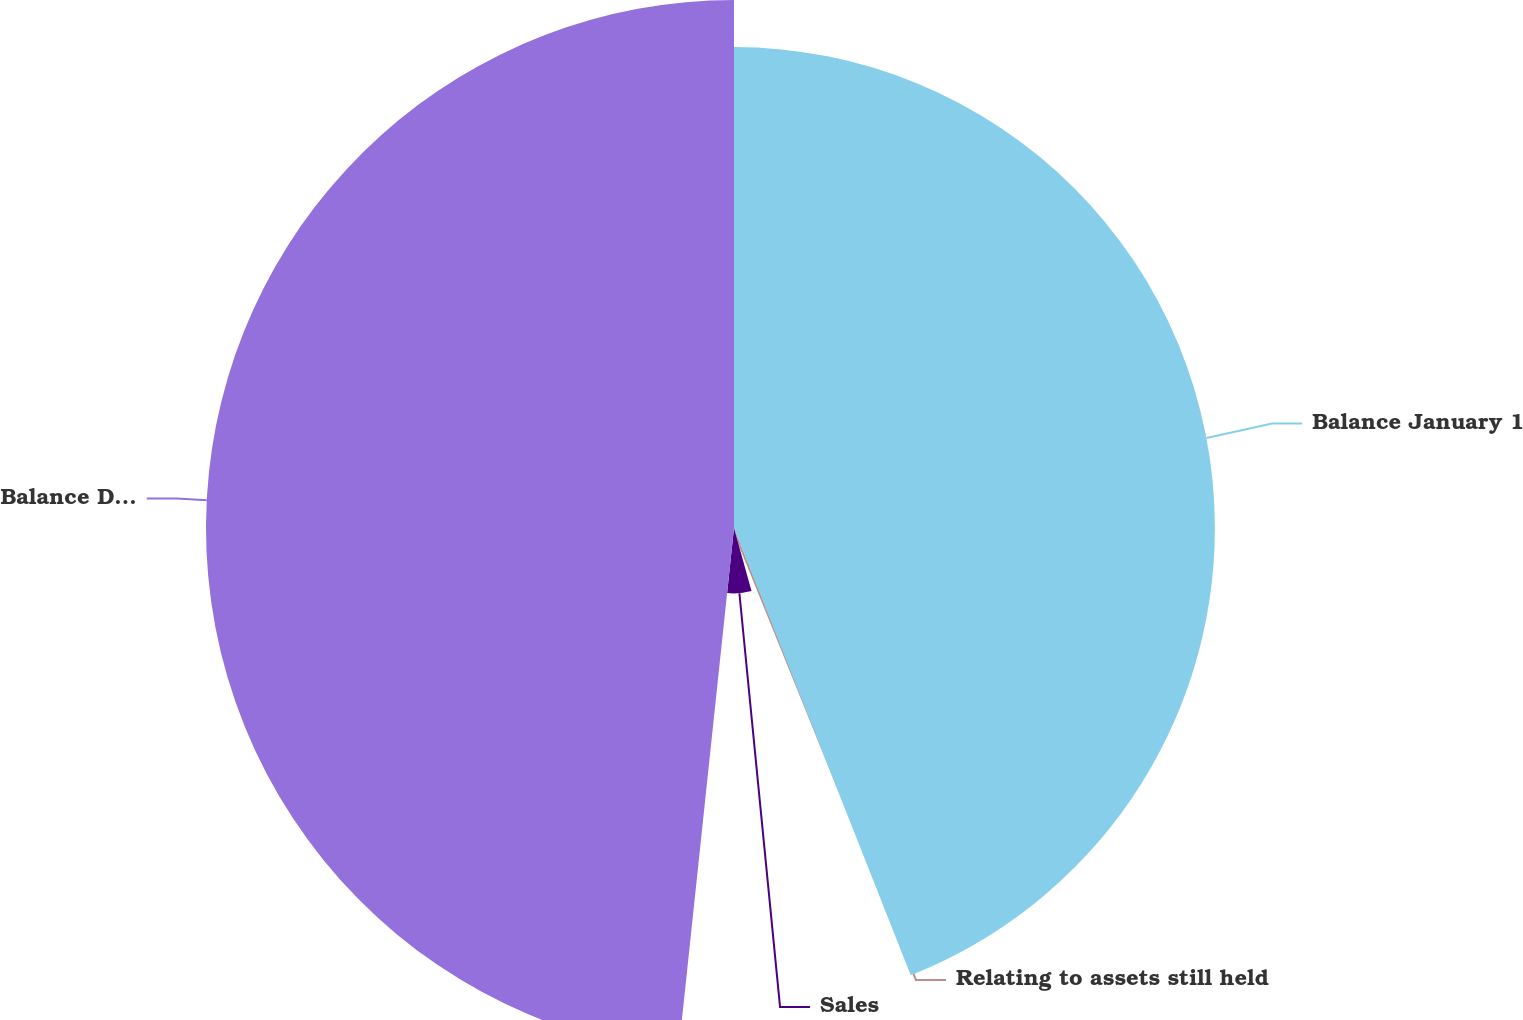<chart> <loc_0><loc_0><loc_500><loc_500><pie_chart><fcel>Balance January 1<fcel>Relating to assets still held<fcel>Sales<fcel>Balance December 31<nl><fcel>44.01%<fcel>1.68%<fcel>5.99%<fcel>48.32%<nl></chart> 